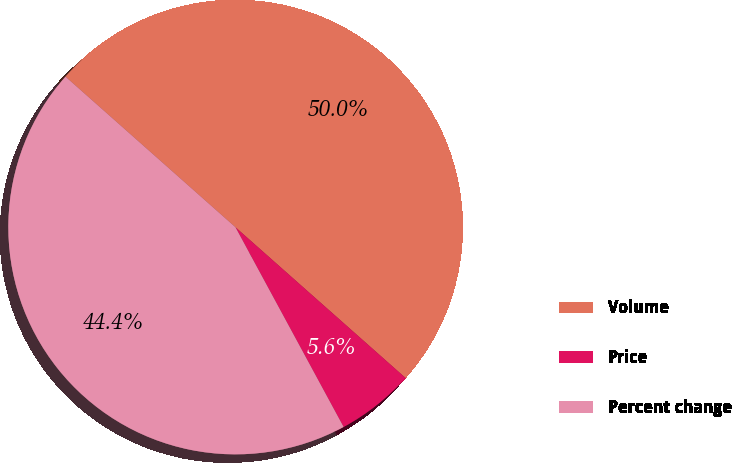Convert chart to OTSL. <chart><loc_0><loc_0><loc_500><loc_500><pie_chart><fcel>Volume<fcel>Price<fcel>Percent change<nl><fcel>50.0%<fcel>5.56%<fcel>44.44%<nl></chart> 